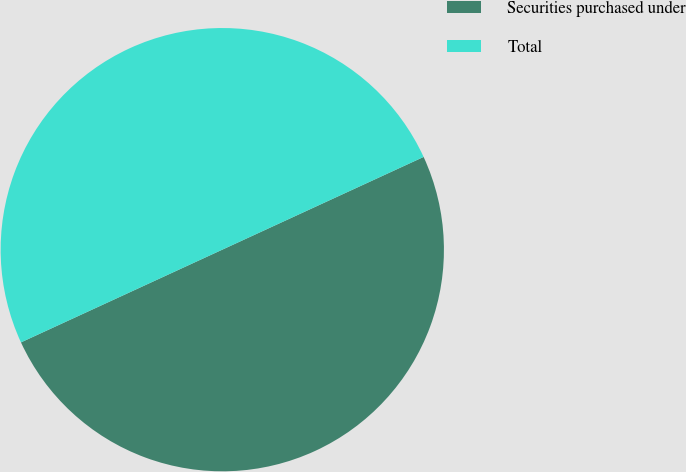Convert chart to OTSL. <chart><loc_0><loc_0><loc_500><loc_500><pie_chart><fcel>Securities purchased under<fcel>Total<nl><fcel>50.0%<fcel>50.0%<nl></chart> 